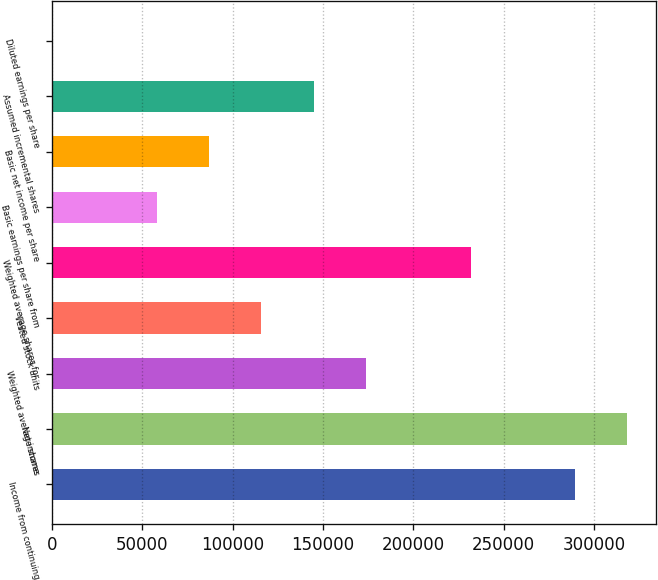Convert chart. <chart><loc_0><loc_0><loc_500><loc_500><bar_chart><fcel>Income from continuing<fcel>Net income<fcel>Weighted average shares<fcel>Vested stock units<fcel>Weighted average shares for<fcel>Basic earnings per share from<fcel>Basic net income per share<fcel>Assumed incremental shares<fcel>Diluted earnings per share<nl><fcel>289329<fcel>318298<fcel>173816<fcel>115878<fcel>231753<fcel>57940.4<fcel>86909.2<fcel>144847<fcel>2.73<nl></chart> 